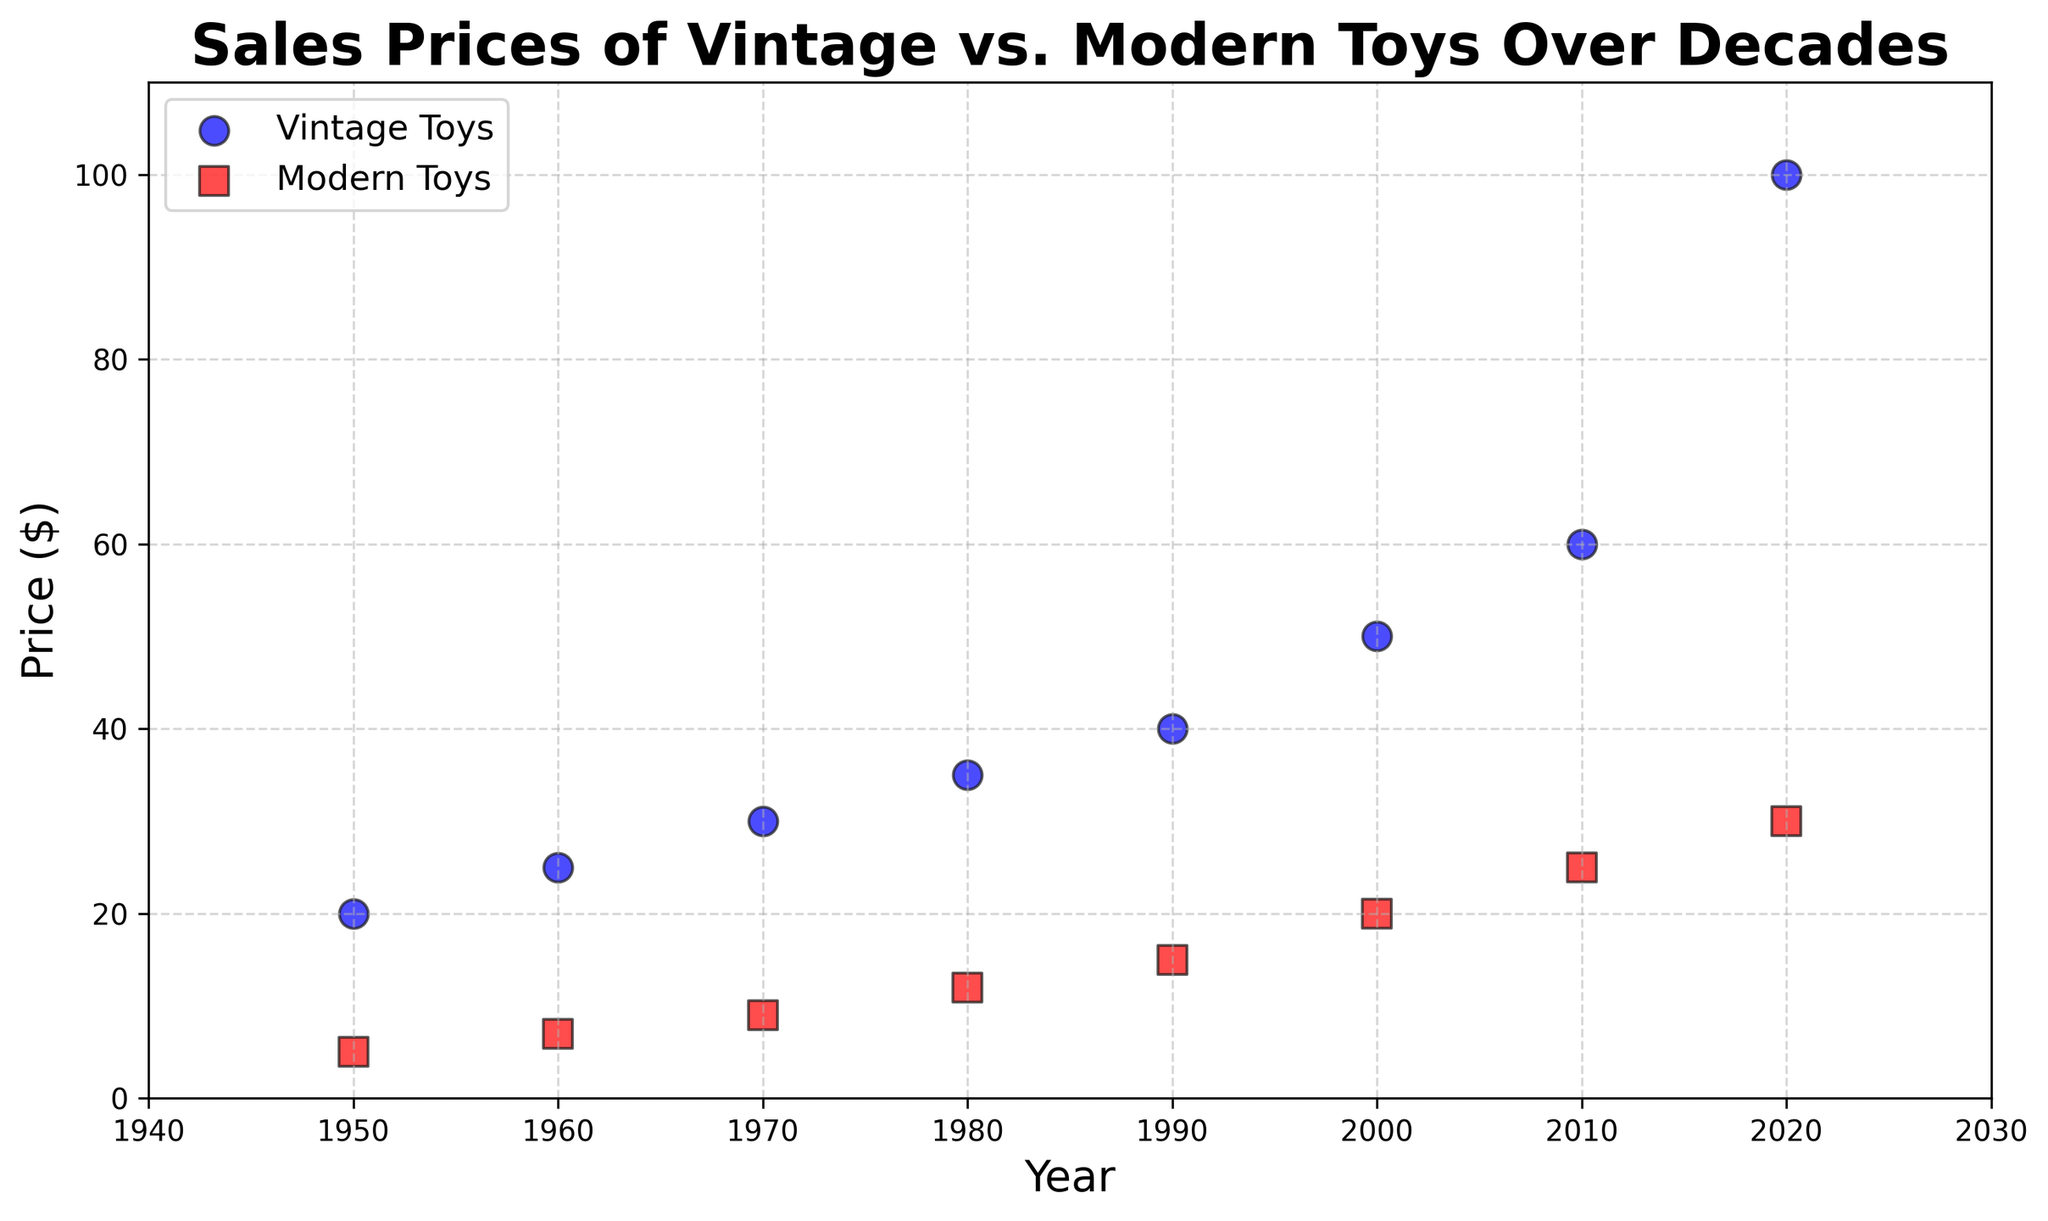1. What was the price of vintage toys in 1980? Locate the blue marker on the scatter plot corresponding to the year 1980, and read the price value, which is 35 dollars.
Answer: 35 2. How much more was the price of vintage toys compared to modern toys in 2020? Find the blue marker representing vintage toys and the red marker representing modern toys in 2020. The price of vintage toys is 100 dollars and that of modern toys is 30 dollars. The difference is 100 - 30 = 70 dollars.
Answer: 70 3. What is the trend in the price of vintage toys from 1950 to 2020? Observe the blue markers' trend over the decades. The prices show a consistent increase from 20 dollars in 1950 to 100 dollars in 2020, indicating a rising trend.
Answer: Rising 4. In which year did modern toys first exceed 20 dollars in price? Look at the red markers representing modern toys on the scatter plot. Modern toys exceeded 20 dollars in the year 2000, where the price was exactly 20 dollars.
Answer: 2000 5. What was the average price of modern toys from 1950 to 2020? Identify the red markers' prices: 5, 7, 9, 12, 15, 20, 25, 30. Sum them up (5 + 7 + 9 + 12 + 15 + 20 + 25 + 30 = 123) and divide by the number of data points (8). The average price is 123 / 8 = 15.375 dollars.
Answer: 15.375 6. How much did the price of vintage toys increase from 1950 to 2000? Locate the blue markers for 1950 and 2000. The price in 1950 was 20 dollars, and in 2000 it was 50 dollars. The increase is 50 - 20 = 30 dollars.
Answer: 30 7. Which type of toys had a higher price in 1990, and by how much? Check both markers for the year 1990. Vintage toys had a price of 40 dollars, and modern toys had a price of 15 dollars. Vintage toys were higher by 40 - 15 = 25 dollars.
Answer: Vintage, 25 8. In which decade did both vintage and modern toys' prices increase by the largest amount? Compare the price increases for each decade. From 2010 to 2020, vintage toys increased by 40 dollars (60 to 100), and modern toys by 5 dollars (25 to 30), which are higher increments compared to other decades.
Answer: 2010-2020 9. What was the combined total price of vintage and modern toys in 1980? Locate both markers for 1980. The price of vintage toys was 35 dollars, and modern toys was 12 dollars. Their combined total price is 35 + 12 = 47 dollars.
Answer: 47 10. Is there any year when the price of modern toys was equal to that of vintage toys? Compare the prices of modern and vintage toy markers for each year. No year shows the same price for both types of toys.
Answer: No 